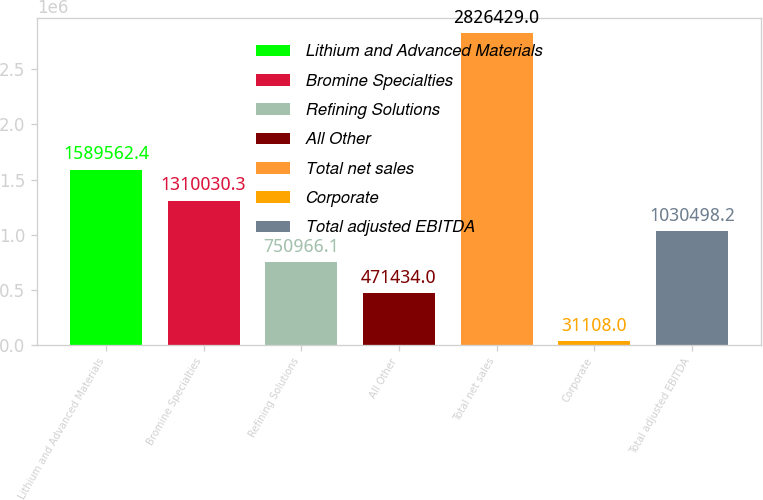Convert chart to OTSL. <chart><loc_0><loc_0><loc_500><loc_500><bar_chart><fcel>Lithium and Advanced Materials<fcel>Bromine Specialties<fcel>Refining Solutions<fcel>All Other<fcel>Total net sales<fcel>Corporate<fcel>Total adjusted EBITDA<nl><fcel>1.58956e+06<fcel>1.31003e+06<fcel>750966<fcel>471434<fcel>2.82643e+06<fcel>31108<fcel>1.0305e+06<nl></chart> 